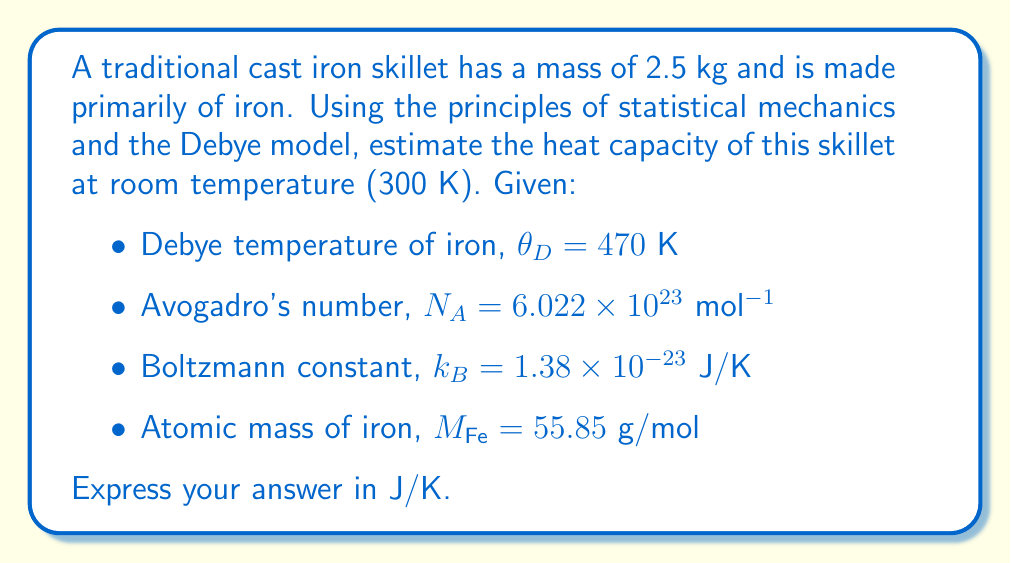Help me with this question. Let's approach this step-by-step using the Debye model:

1) First, we need to calculate the number of atoms in our skillet:
   $n = \frac{m}{M_{Fe}} \times N_A = \frac{2.5 \times 10^3 \text{ g}}{55.85 \text{ g/mol}} \times 6.022 \times 10^{23} \text{ mol}^{-1} = 2.70 \times 10^{25}$ atoms

2) The Debye model gives us the heat capacity per atom as:
   $C_V = 3k_B D(\frac{\theta_D}{T})$
   where $D(x)$ is the Debye function.

3) At high temperatures (T > $\theta_D$), the Debye function approaches 1, and we get the classical Dulong-Petit result:
   $C_V \approx 3k_B$ per atom

4) In our case, $T = 300$ K and $\theta_D = 470$ K, so we're not quite in the high-temperature limit. However, we can use this as an approximation.

5) The total heat capacity of the skillet is then:
   $C_{total} \approx n \times 3k_B$

6) Plugging in our values:
   $C_{total} \approx 2.70 \times 10^{25} \times 3 \times 1.38 \times 10^{-23} \text{ J/K} = 1118.34 \text{ J/K}$

This estimation slightly overestimates the heat capacity because we're not fully in the high-temperature limit, but it provides a good approximation for our traditional cast iron skillet.
Answer: $1118 \text{ J/K}$ 